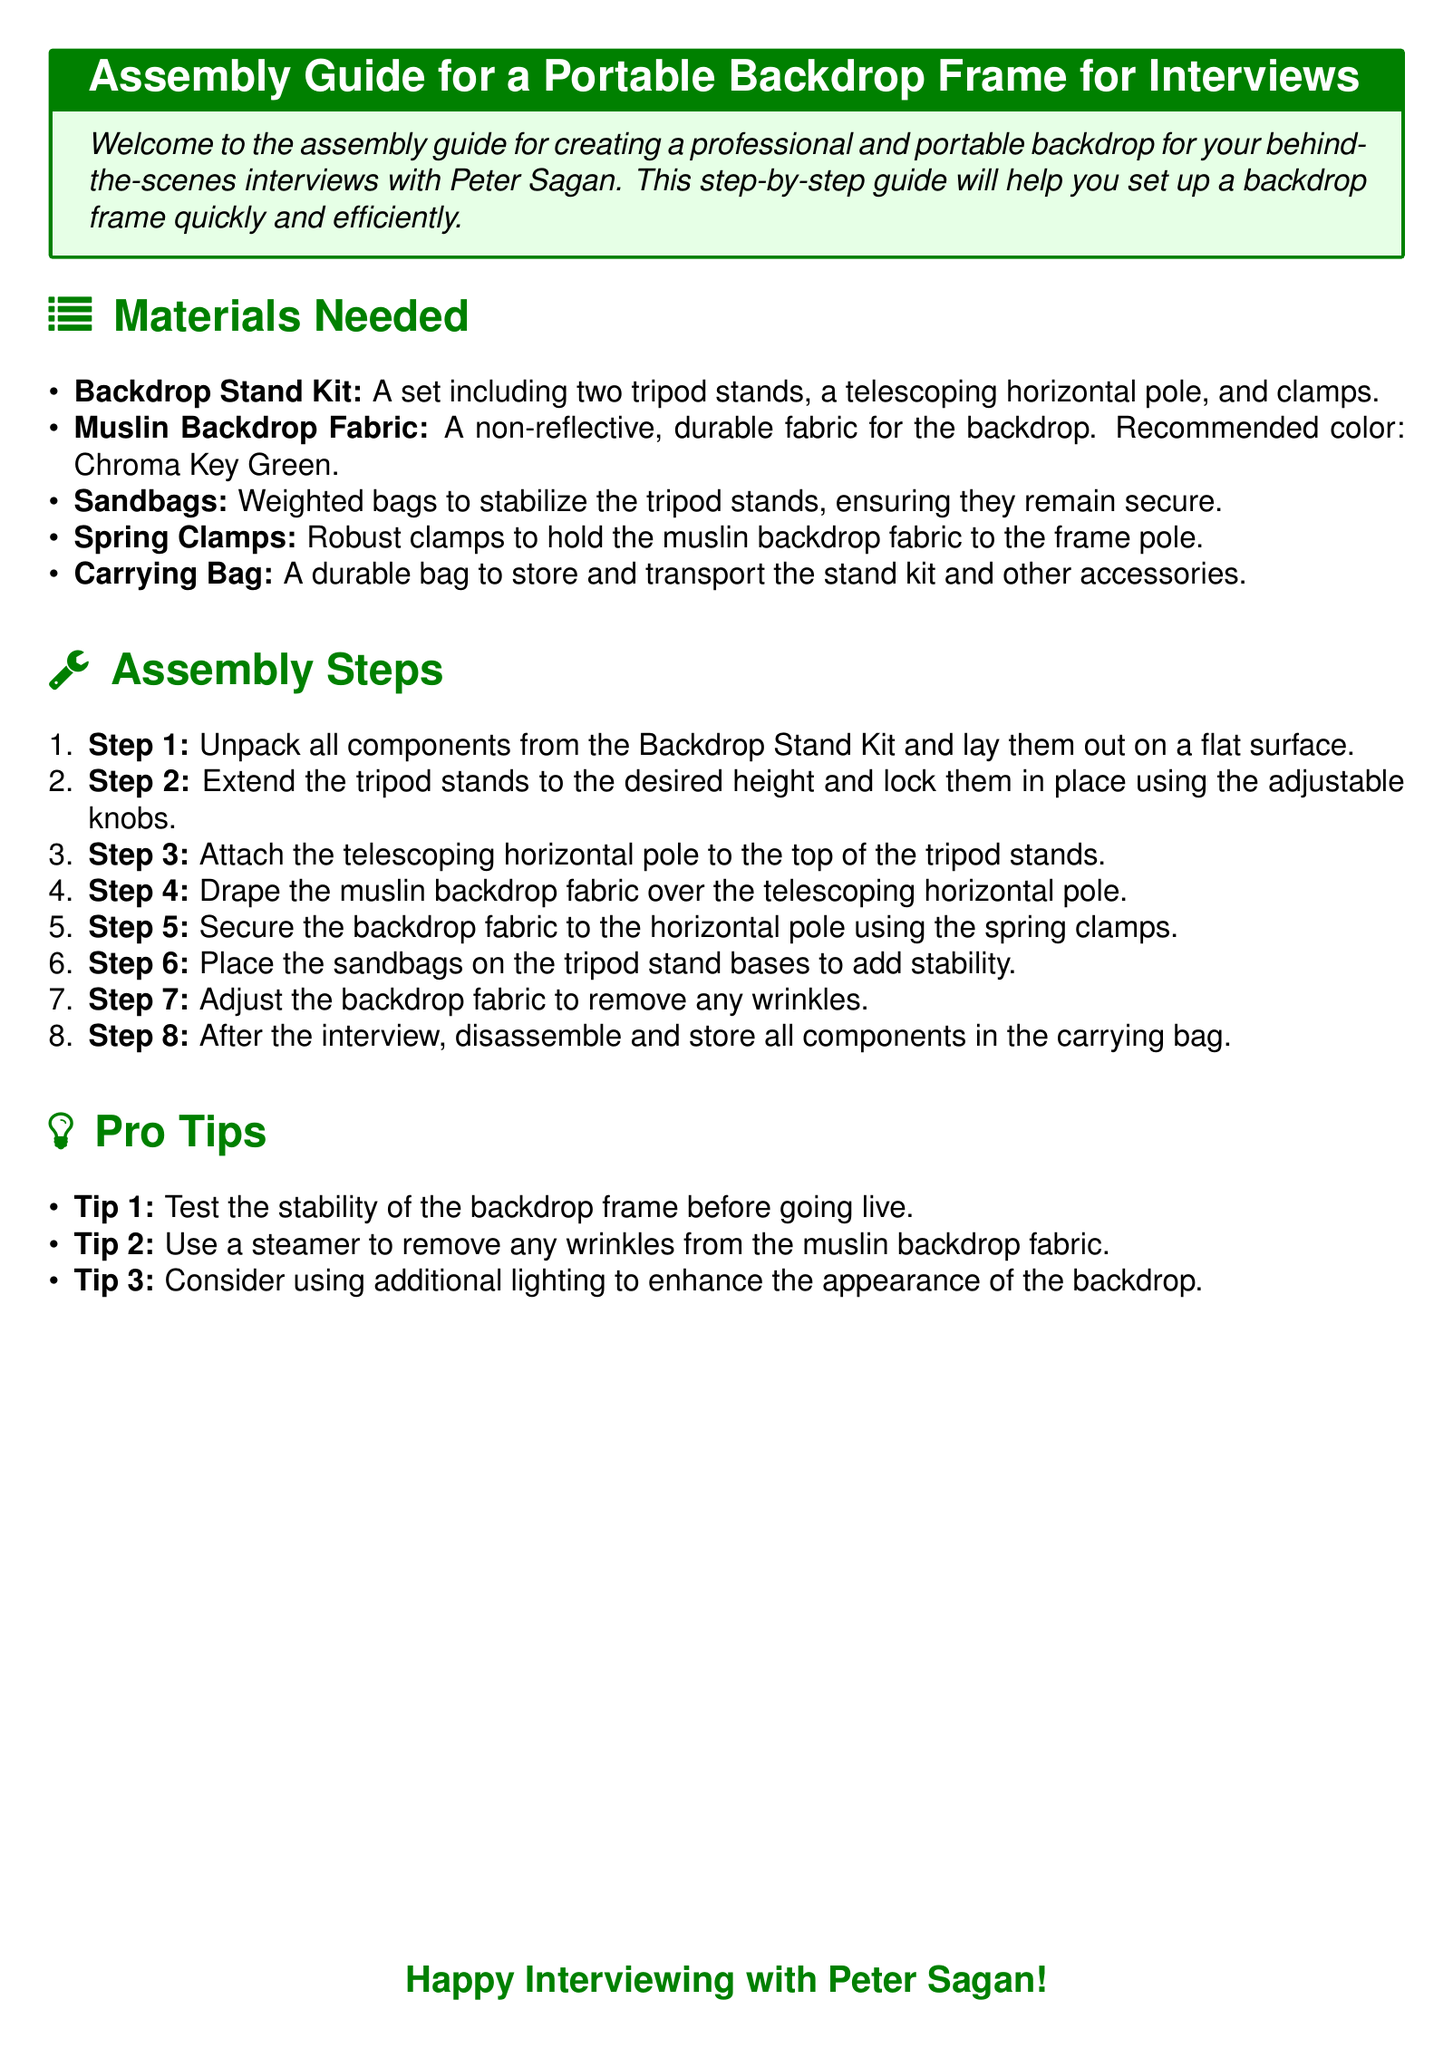What is the recommended color for the muslin backdrop? The document states that the recommended color for the muslin backdrop is Chroma Key Green.
Answer: Chroma Key Green How many tripod stands are included in the backdrop stand kit? The backdrop stand kit includes two tripod stands as mentioned in the materials needed section.
Answer: Two tripod stands What step involves securing the backdrop fabric? Step 5 mentions securing the backdrop fabric to the horizontal pole using spring clamps.
Answer: Step 5 What should be placed on the tripod stand bases for stability? The document specifies that sandbags should be placed on the tripod stand bases to ensure stability.
Answer: Sandbags What is the total number of assembly steps? The assembly steps are listed as eight, according to the enumeration provided in the document.
Answer: Eight steps Which tool is suggested to remove wrinkles from the muslin fabric? The document recommends using a steamer to remove wrinkles from the muslin backdrop fabric as stated in the tips section.
Answer: Steamer What item is used to hold the muslin backdrop fabric? The robust clamps mentioned are used to hold the muslin backdrop fabric to the frame pole.
Answer: Spring Clamps What should you do after the interview according to the instructions? The document instructs to disassemble and store all components in the carrying bag after the interview.
Answer: Disassemble and store 